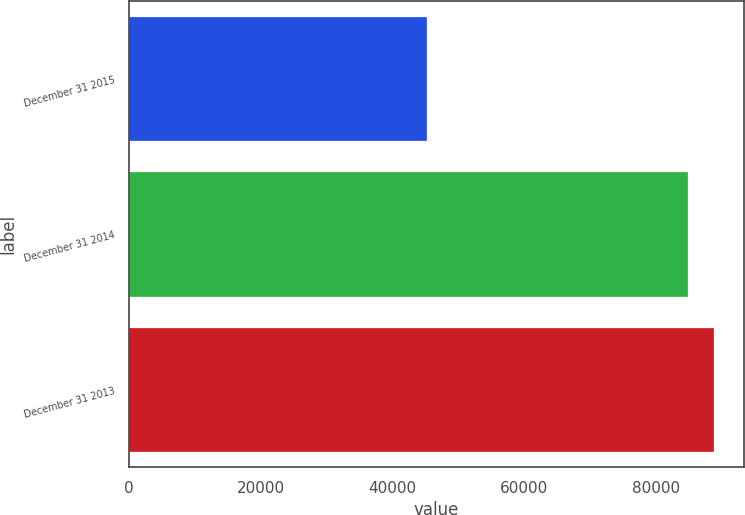<chart> <loc_0><loc_0><loc_500><loc_500><bar_chart><fcel>December 31 2015<fcel>December 31 2014<fcel>December 31 2013<nl><fcel>45313<fcel>84891<fcel>88906.4<nl></chart> 